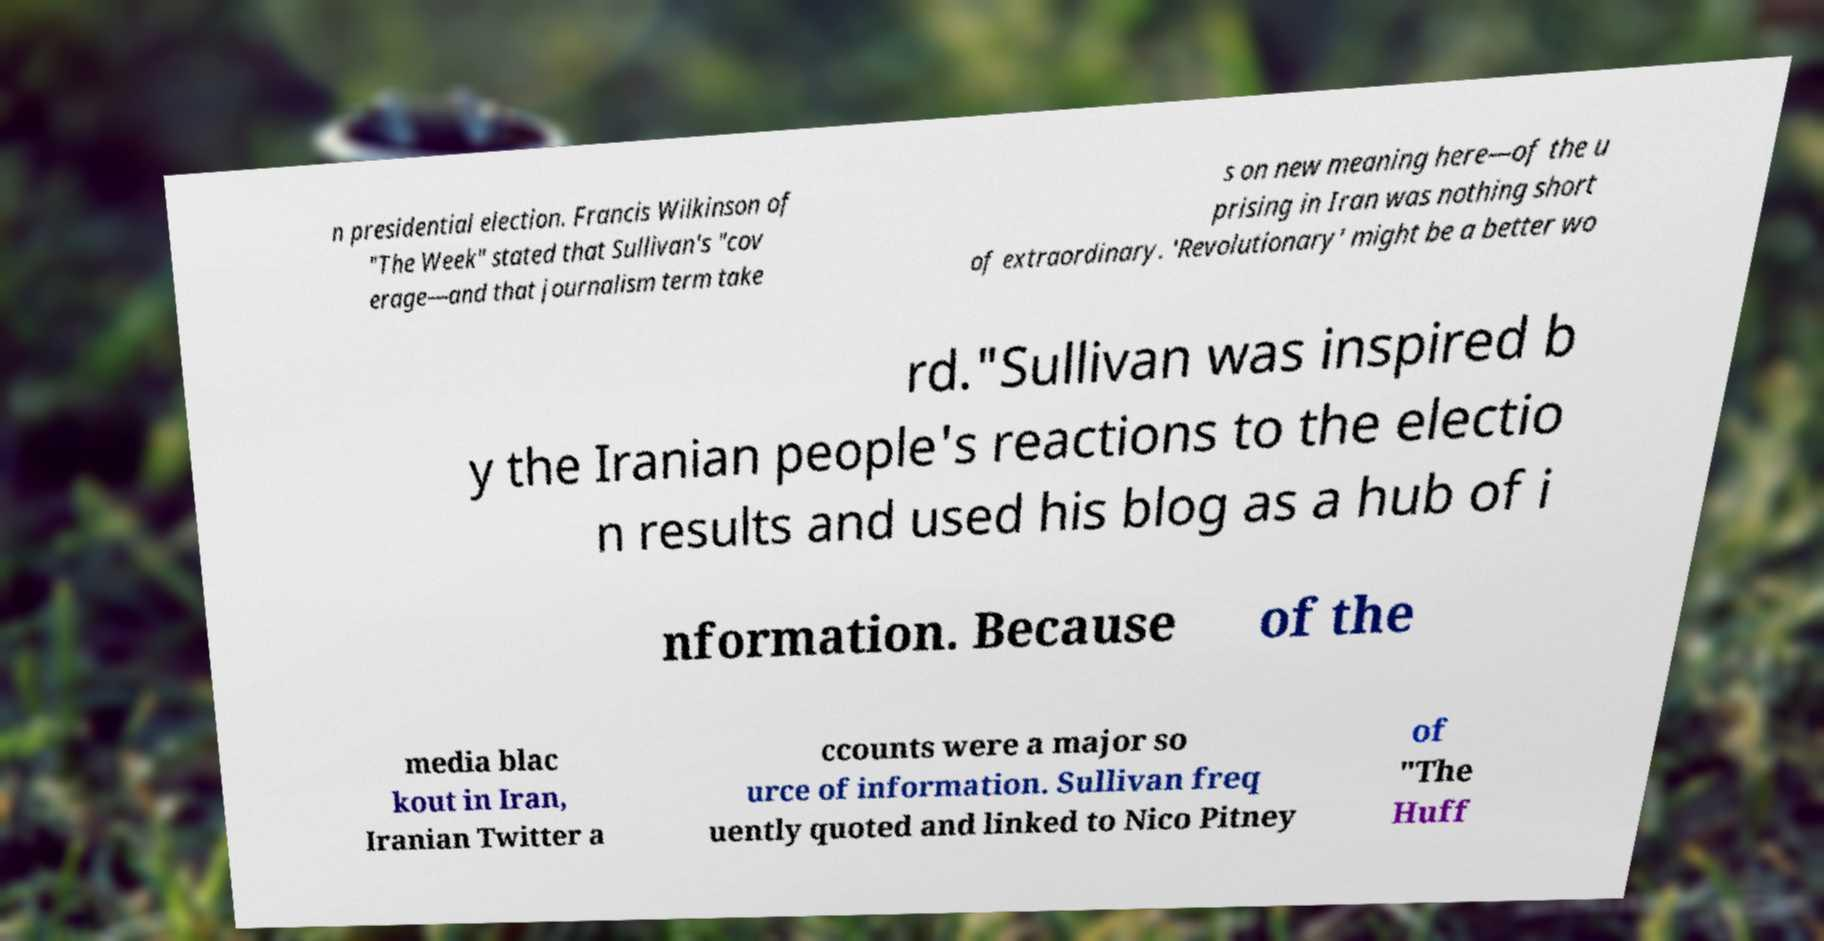There's text embedded in this image that I need extracted. Can you transcribe it verbatim? n presidential election. Francis Wilkinson of "The Week" stated that Sullivan's "cov erage—and that journalism term take s on new meaning here—of the u prising in Iran was nothing short of extraordinary. 'Revolutionary' might be a better wo rd."Sullivan was inspired b y the Iranian people's reactions to the electio n results and used his blog as a hub of i nformation. Because of the media blac kout in Iran, Iranian Twitter a ccounts were a major so urce of information. Sullivan freq uently quoted and linked to Nico Pitney of "The Huff 